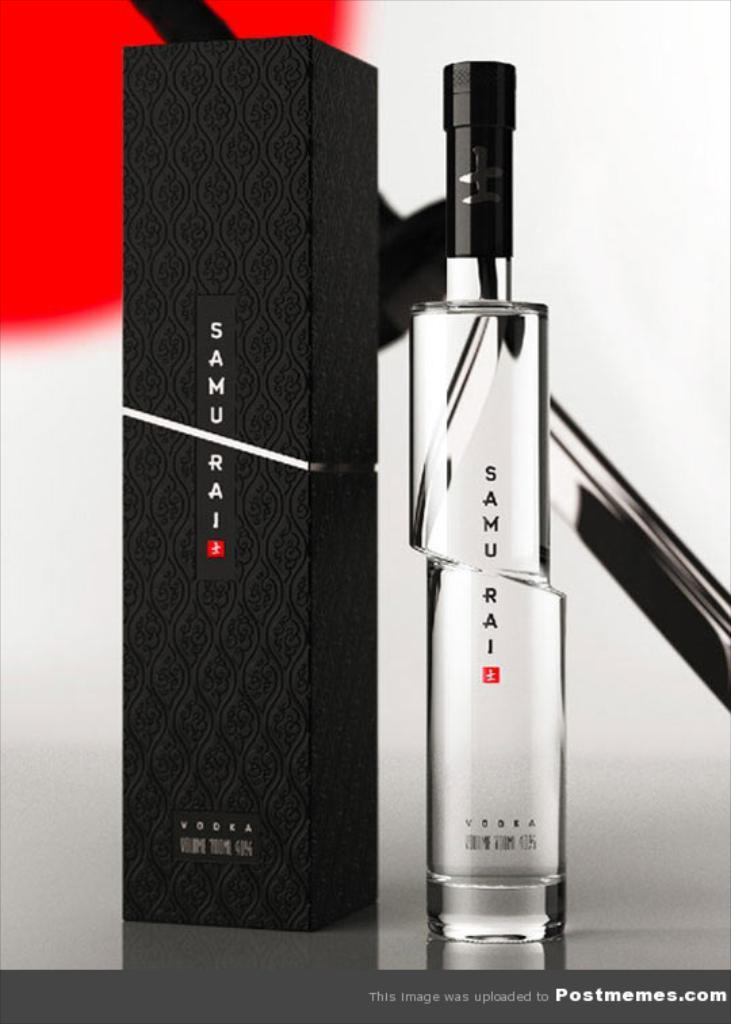Provide a one-sentence caption for the provided image. A bottle of Samu Rai Vodka is sitting next to a black box. 